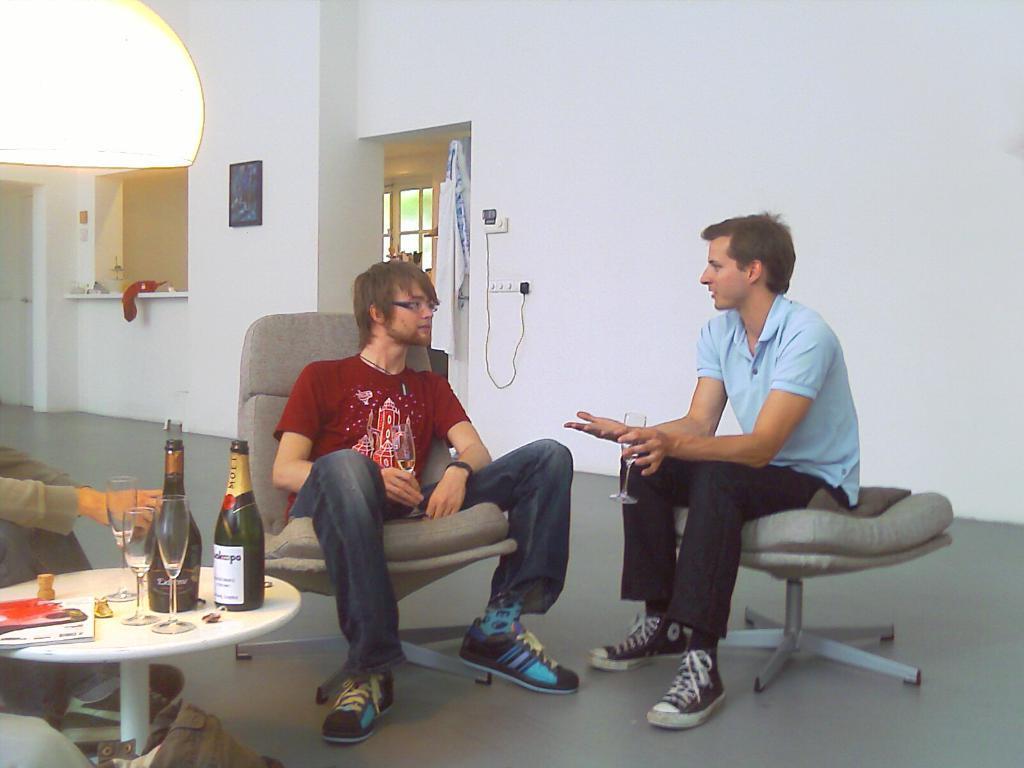Could you give a brief overview of what you see in this image? There are two men sitting in the chair holding a glasses in their hands. On the table, there are books, two glasses two wine bottles were present. In a background there is a wall and a photo frame attached to it. 